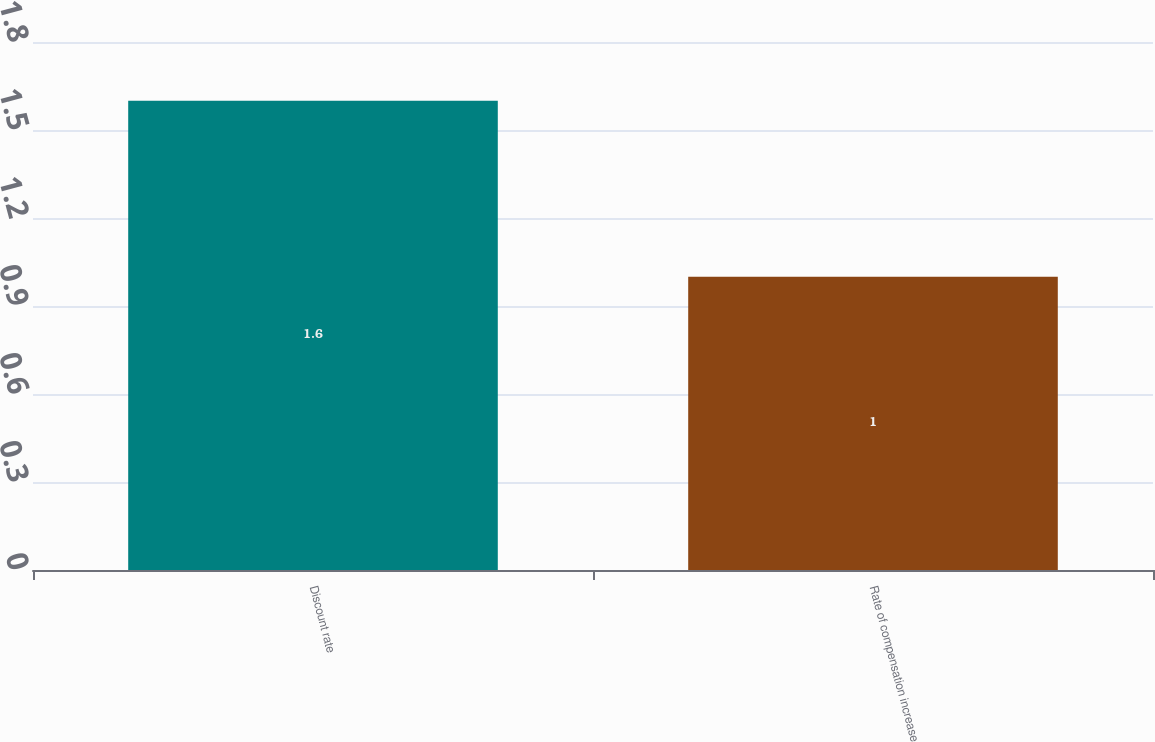Convert chart. <chart><loc_0><loc_0><loc_500><loc_500><bar_chart><fcel>Discount rate<fcel>Rate of compensation increase<nl><fcel>1.6<fcel>1<nl></chart> 